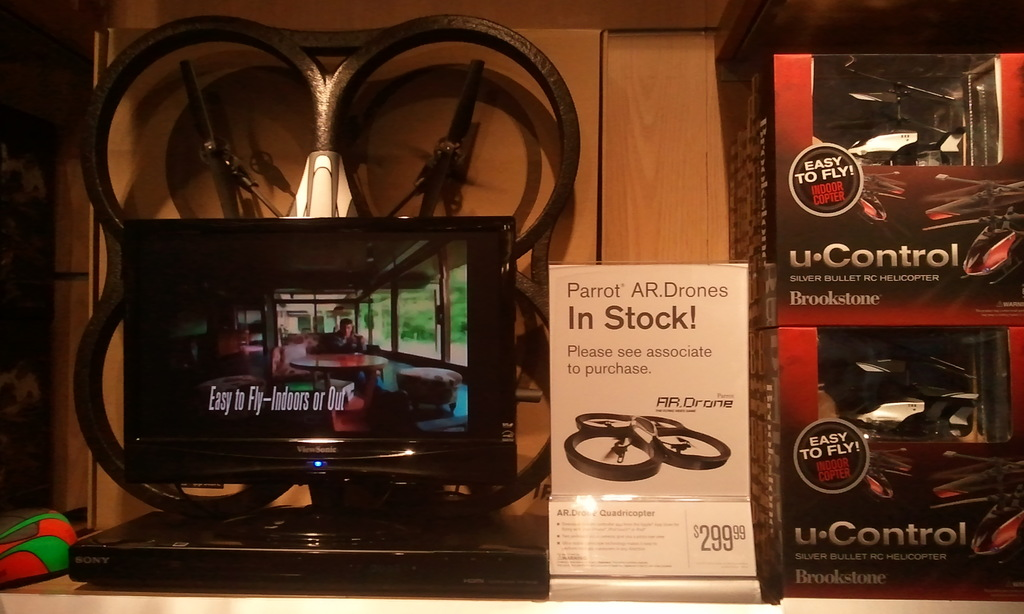Can you describe the setting and potential target audience for these drones based on the image? The image suggests a retail setting, likely a technology or hobby store, aimed at consumers interested in recreational technologies. The clear, informative display targets both beginner and experienced drone enthusiasts interested in versatile, easy-to-operate models. 